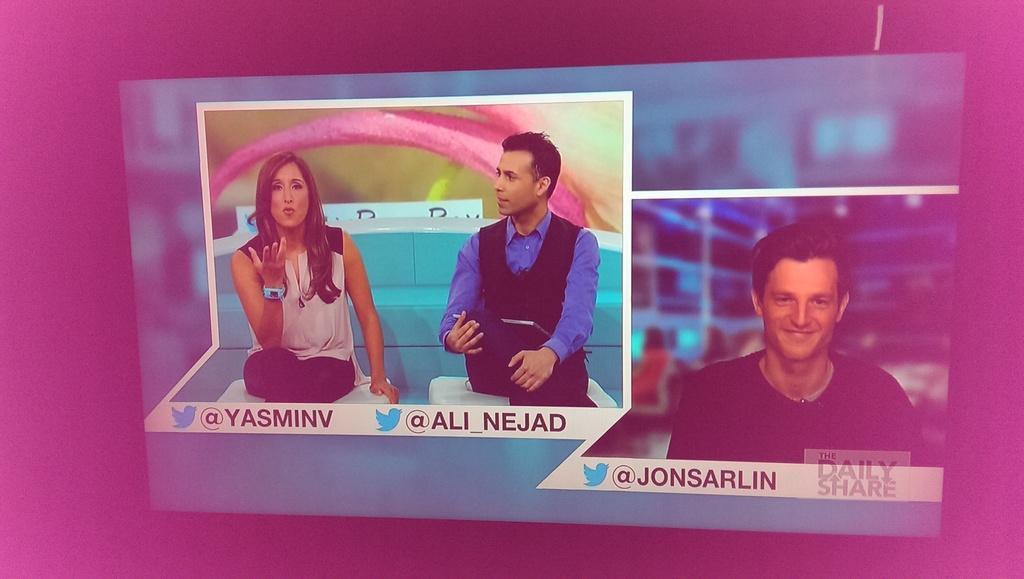How would you summarize this image in a sentence or two? This is an edited image. In this image we can see a man and a woman sitting on the chairs. On the right side we can see a person. We can also see some text on it. 